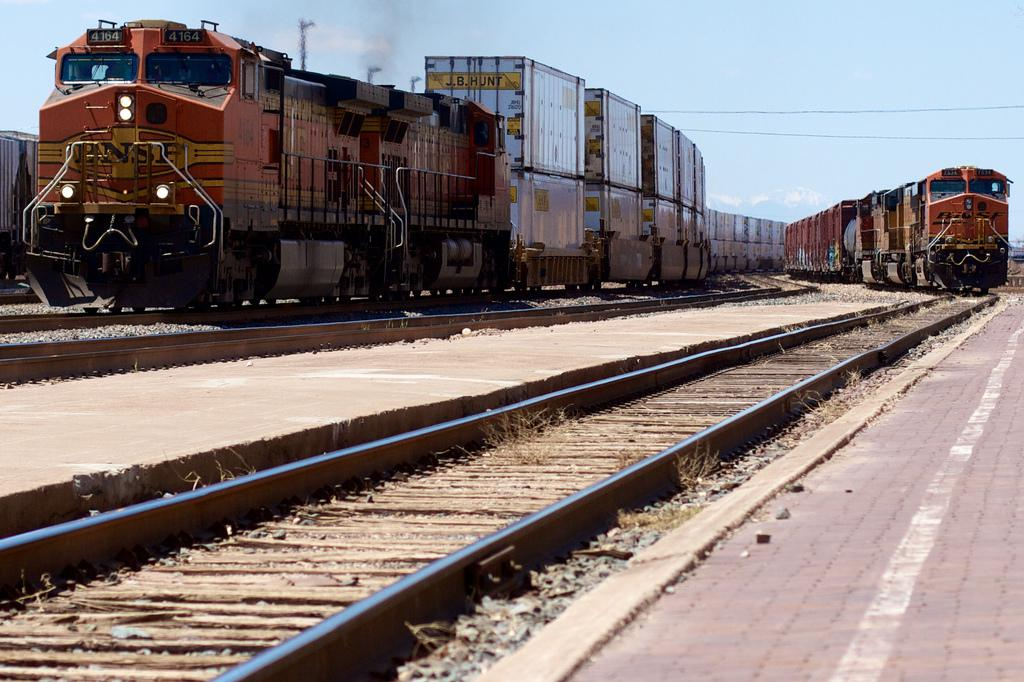Question: how many trains are there?
Choices:
A. Three.
B. One.
C. Four.
D. Two.
Answer with the letter. Answer: D Question: why are there trains?
Choices:
A. Railways.
B. Passengers.
C. Cabooses.
D. There are train tracks.
Answer with the letter. Answer: D Question: what color are the trains?
Choices:
A. White.
B. Silver.
C. Grey.
D. Orange.
Answer with the letter. Answer: D Question: what are the trains transporting?
Choices:
A. White trailers.
B. Black trailers.
C. Green trailers.
D. Blue trailers.
Answer with the letter. Answer: A Question: when is the picture taken?
Choices:
A. Rainy day.
B. Cloudy day.
C. During a sunny day.
D. Foggy day.
Answer with the letter. Answer: C Question: where is the picture taken?
Choices:
A. At a traintracks.
B. At the corner.
C. At the crosswalk.
D. At the end of the road.
Answer with the letter. Answer: A Question: how many trains are there?
Choices:
A. Four.
B. Two.
C. One.
D. Five.
Answer with the letter. Answer: B Question: where does the weed grow?
Choices:
A. Through cracks.
B. Through crevices.
C. Through out the garden.
D. Through tracks.
Answer with the letter. Answer: D Question: how is the weather?
Choices:
A. Clear.
B. Mild.
C. Sunny.
D. Warm.
Answer with the letter. Answer: A Question: what does the train pull?
Choices:
A. Freight cars.
B. Passenger cars.
C. Box cars.
D. Caboose.
Answer with the letter. Answer: C Question: what are there not any of?
Choices:
A. Cars.
B. Trucks.
C. Vans.
D. Passenger trains.
Answer with the letter. Answer: D Question: what is the color of the stripe down the side of the landing?
Choices:
A. White.
B. Blue.
C. Yellow.
D. Red.
Answer with the letter. Answer: A Question: what on the left is pulling containers that are piled on top of each other?
Choices:
A. A truck.
B. A tractor.
C. A mule.
D. The train.
Answer with the letter. Answer: D Question: how is the walkway next to the trains paved?
Choices:
A. With asphalt.
B. With concrete.
C. With red bricks.
D. Not at all.
Answer with the letter. Answer: C Question: what on the other side of the closest one approaching?
Choices:
A. A train.
B. A caboose.
C. A pick up truck.
D. The engine house.
Answer with the letter. Answer: A Question: where does the white line runs?
Choices:
A. Down the street.
B. Along the building.
C. Down the center of the brick path.
D. To the end of the path.
Answer with the letter. Answer: C Question: what might be parked on a side-track?
Choices:
A. The train on the right.
B. A van.
C. A green train to the left.
D. A man on a golf cart.
Answer with the letter. Answer: A 